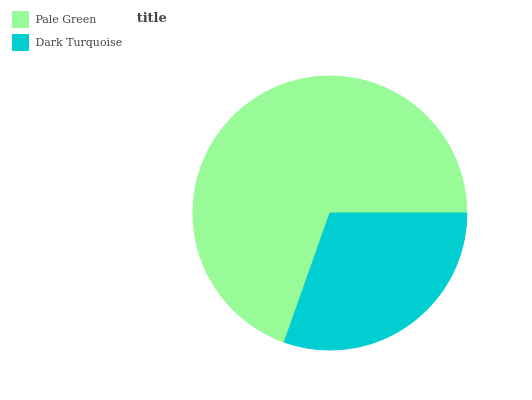Is Dark Turquoise the minimum?
Answer yes or no. Yes. Is Pale Green the maximum?
Answer yes or no. Yes. Is Dark Turquoise the maximum?
Answer yes or no. No. Is Pale Green greater than Dark Turquoise?
Answer yes or no. Yes. Is Dark Turquoise less than Pale Green?
Answer yes or no. Yes. Is Dark Turquoise greater than Pale Green?
Answer yes or no. No. Is Pale Green less than Dark Turquoise?
Answer yes or no. No. Is Pale Green the high median?
Answer yes or no. Yes. Is Dark Turquoise the low median?
Answer yes or no. Yes. Is Dark Turquoise the high median?
Answer yes or no. No. Is Pale Green the low median?
Answer yes or no. No. 